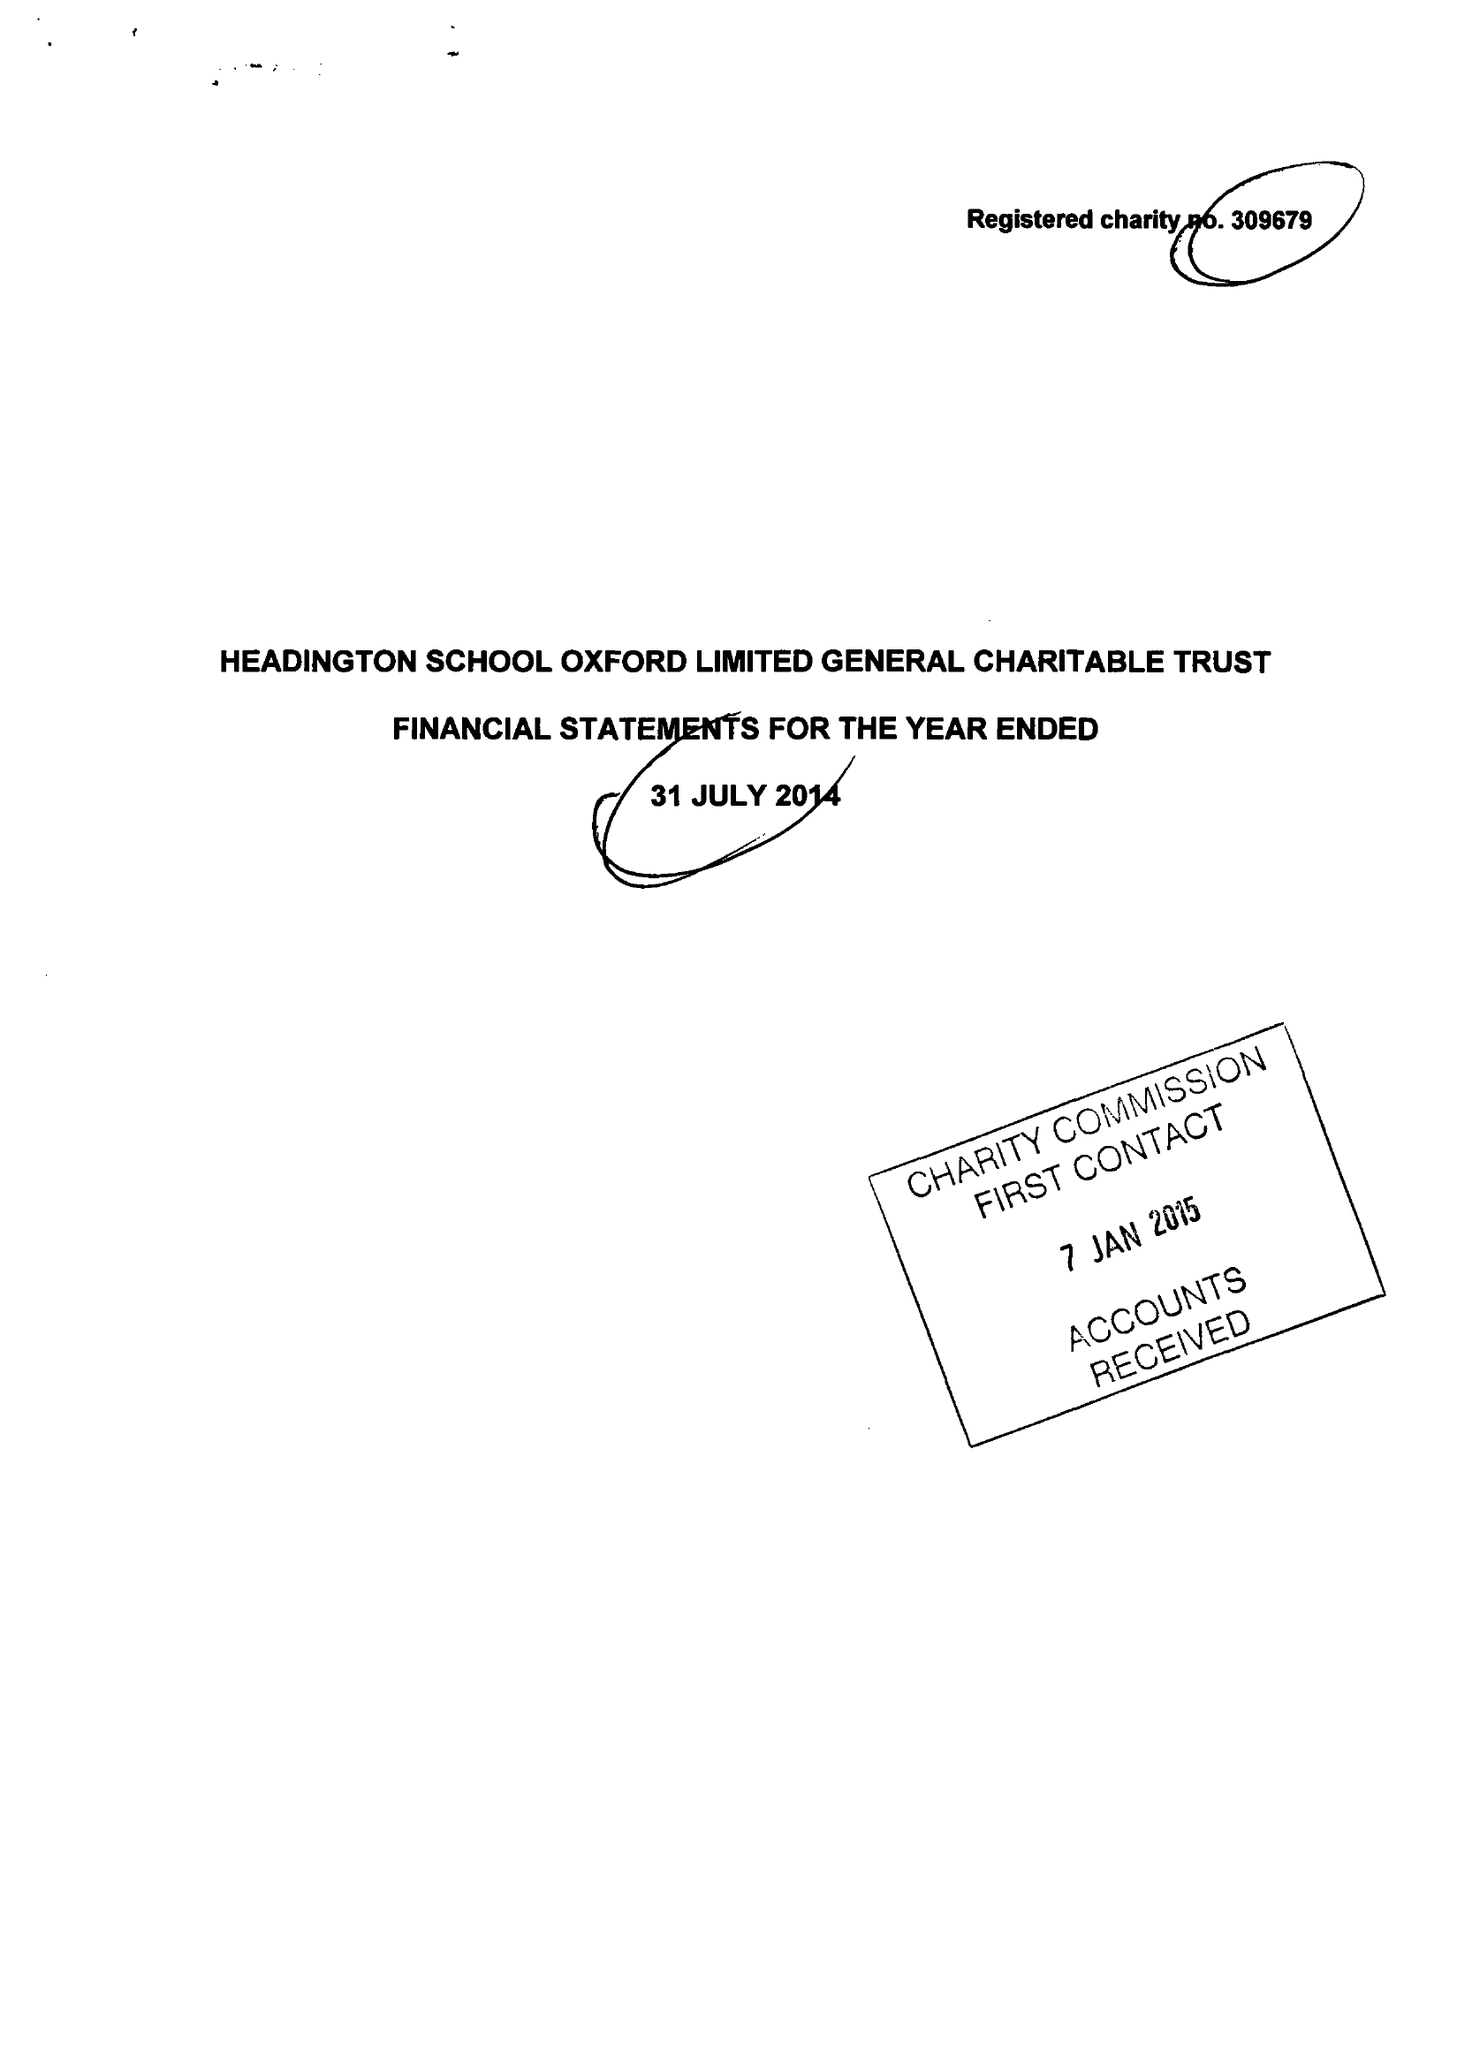What is the value for the address__street_line?
Answer the question using a single word or phrase. 24 CHILTON FIELD WAY 